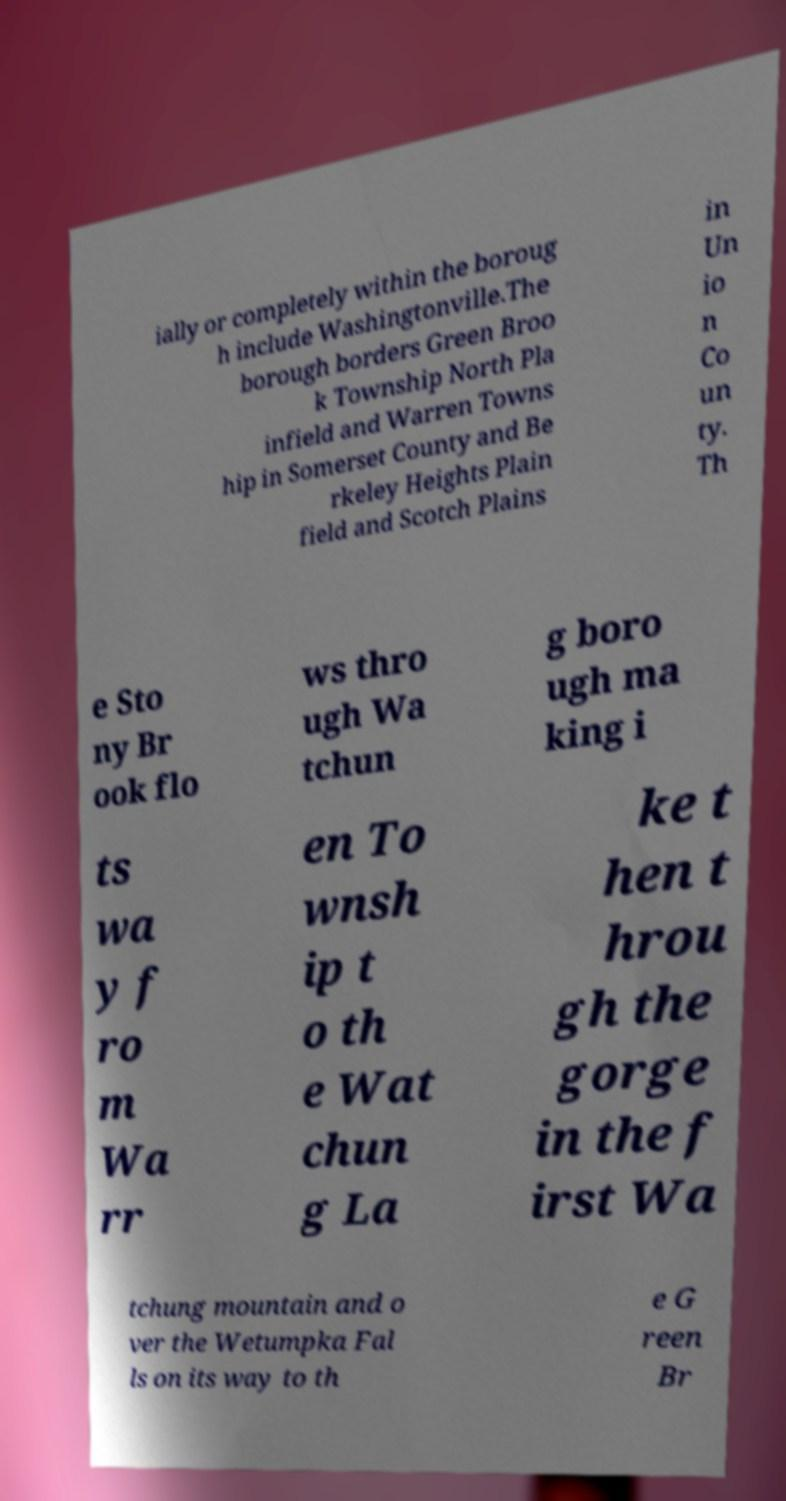I need the written content from this picture converted into text. Can you do that? ially or completely within the boroug h include Washingtonville.The borough borders Green Broo k Township North Pla infield and Warren Towns hip in Somerset County and Be rkeley Heights Plain field and Scotch Plains in Un io n Co un ty. Th e Sto ny Br ook flo ws thro ugh Wa tchun g boro ugh ma king i ts wa y f ro m Wa rr en To wnsh ip t o th e Wat chun g La ke t hen t hrou gh the gorge in the f irst Wa tchung mountain and o ver the Wetumpka Fal ls on its way to th e G reen Br 